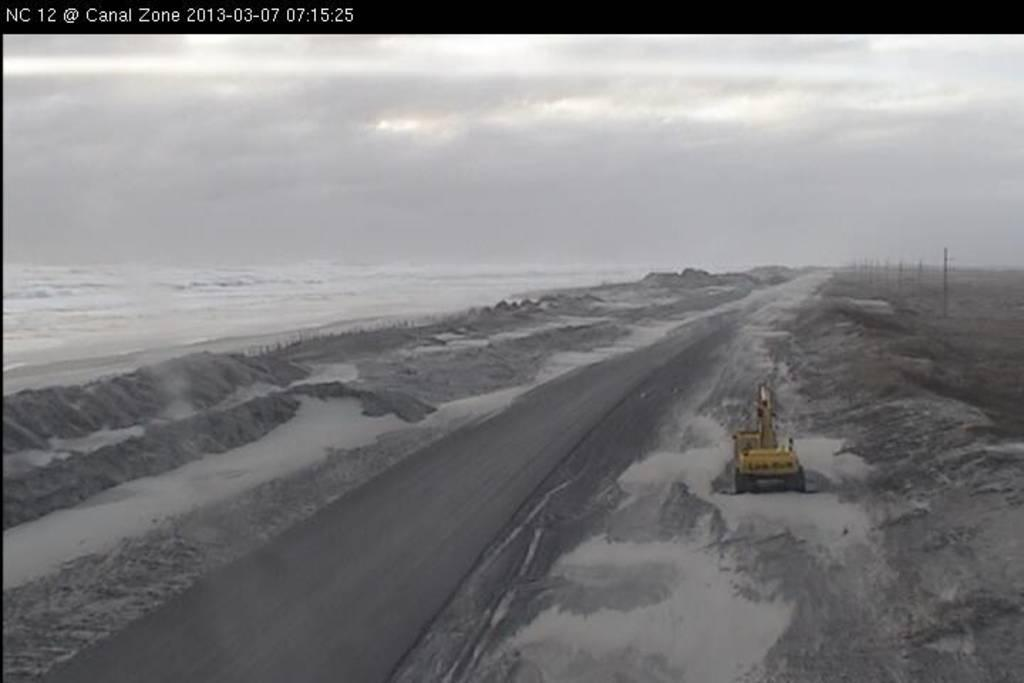What is the color scheme of the image? The image is black and white. What can be seen in the image besides the color scheme? There is a vehicle, sand, water, and the sky visible in the image. Can you describe the setting of the image? The image appears to be set near a body of water, with sand and a vehicle present. Is there any text or marking on the image? Yes, there is a watermark on the image. What type of crate is being smashed by the vehicle in the image? There is no crate present in the image, nor is there any indication of a vehicle smashing anything. 